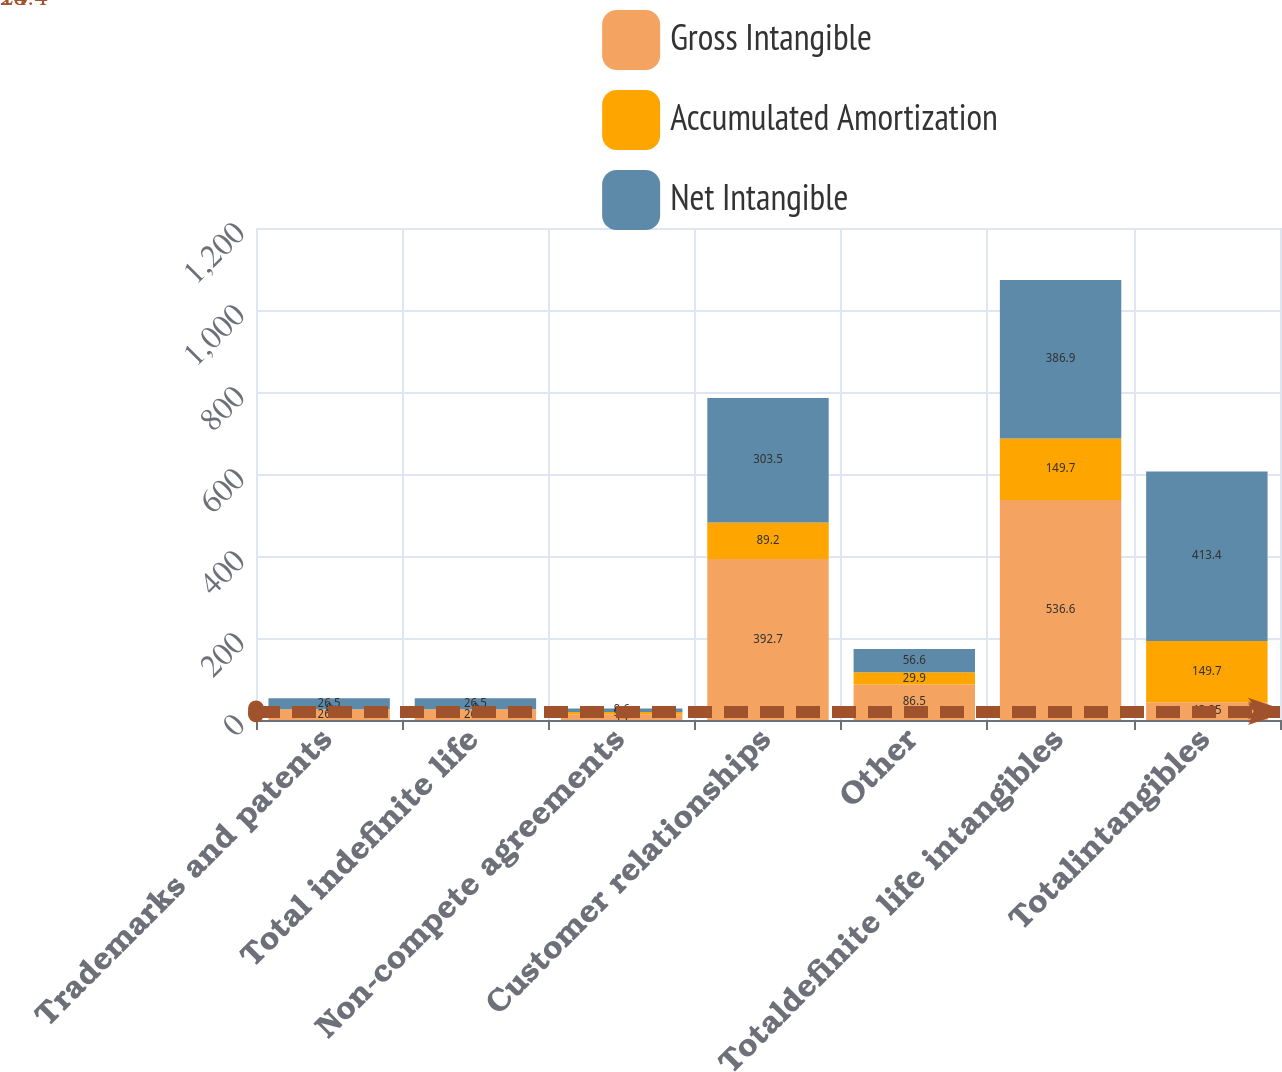<chart> <loc_0><loc_0><loc_500><loc_500><stacked_bar_chart><ecel><fcel>Trademarks and patents<fcel>Total indefinite life<fcel>Non-compete agreements<fcel>Customer relationships<fcel>Other<fcel>Totaldefinite life intangibles<fcel>Totalintangibles<nl><fcel>Gross Intangible<fcel>26.5<fcel>26.5<fcel>14<fcel>392.7<fcel>86.5<fcel>536.6<fcel>43.25<nl><fcel>Accumulated Amortization<fcel>0<fcel>0<fcel>5.4<fcel>89.2<fcel>29.9<fcel>149.7<fcel>149.7<nl><fcel>Net Intangible<fcel>26.5<fcel>26.5<fcel>8.6<fcel>303.5<fcel>56.6<fcel>386.9<fcel>413.4<nl></chart> 